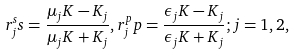Convert formula to latex. <formula><loc_0><loc_0><loc_500><loc_500>r _ { j } ^ { s } s = \frac { \mu _ { j } K - K _ { j } } { \mu _ { j } K + K _ { j } } , r _ { j } ^ { p } p = \frac { \epsilon _ { j } K - K _ { j } } { \epsilon _ { j } K + K _ { j } } ; j = 1 , 2 ,</formula> 